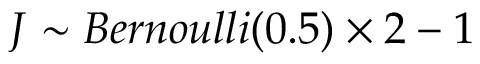Convert formula to latex. <formula><loc_0><loc_0><loc_500><loc_500>J \sim B e r n o u l l i ( 0 . 5 ) \times 2 - 1</formula> 